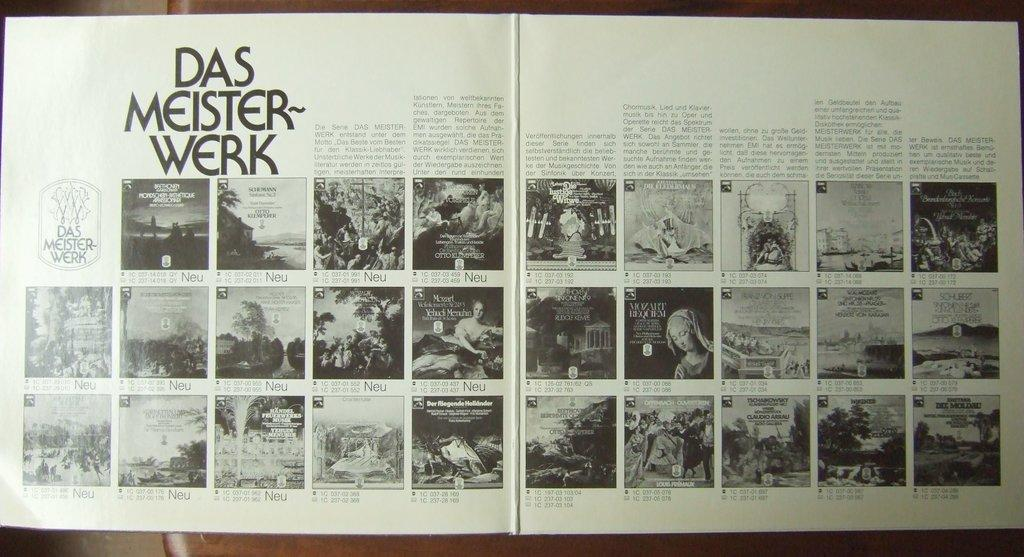<image>
Describe the image concisely. A catalogue is open to a section titled Das Meister-werk. 